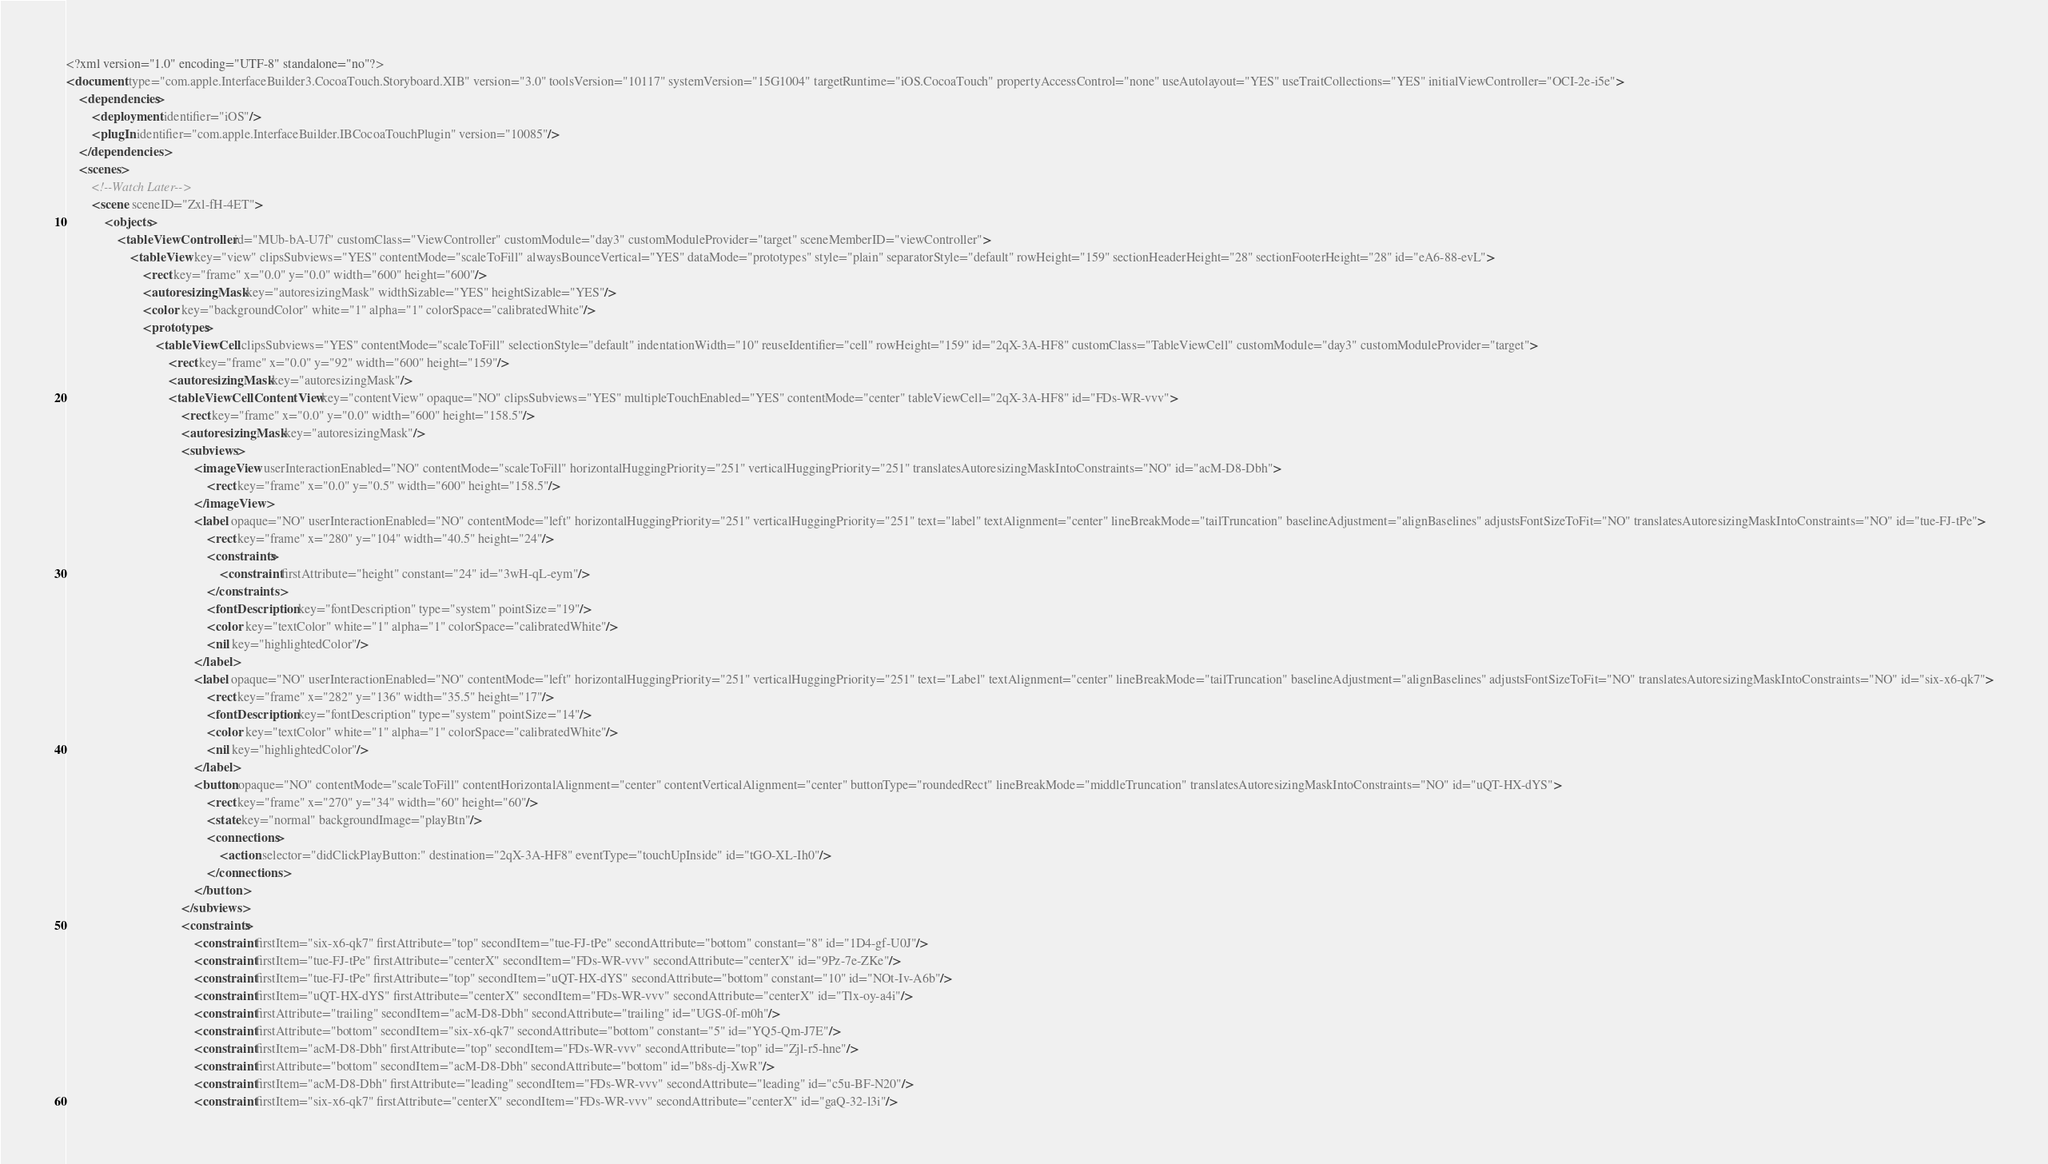<code> <loc_0><loc_0><loc_500><loc_500><_XML_><?xml version="1.0" encoding="UTF-8" standalone="no"?>
<document type="com.apple.InterfaceBuilder3.CocoaTouch.Storyboard.XIB" version="3.0" toolsVersion="10117" systemVersion="15G1004" targetRuntime="iOS.CocoaTouch" propertyAccessControl="none" useAutolayout="YES" useTraitCollections="YES" initialViewController="OCI-2e-i5e">
    <dependencies>
        <deployment identifier="iOS"/>
        <plugIn identifier="com.apple.InterfaceBuilder.IBCocoaTouchPlugin" version="10085"/>
    </dependencies>
    <scenes>
        <!--Watch Later-->
        <scene sceneID="Zxl-fH-4ET">
            <objects>
                <tableViewController id="MUb-bA-U7f" customClass="ViewController" customModule="day3" customModuleProvider="target" sceneMemberID="viewController">
                    <tableView key="view" clipsSubviews="YES" contentMode="scaleToFill" alwaysBounceVertical="YES" dataMode="prototypes" style="plain" separatorStyle="default" rowHeight="159" sectionHeaderHeight="28" sectionFooterHeight="28" id="eA6-88-evL">
                        <rect key="frame" x="0.0" y="0.0" width="600" height="600"/>
                        <autoresizingMask key="autoresizingMask" widthSizable="YES" heightSizable="YES"/>
                        <color key="backgroundColor" white="1" alpha="1" colorSpace="calibratedWhite"/>
                        <prototypes>
                            <tableViewCell clipsSubviews="YES" contentMode="scaleToFill" selectionStyle="default" indentationWidth="10" reuseIdentifier="cell" rowHeight="159" id="2qX-3A-HF8" customClass="TableViewCell" customModule="day3" customModuleProvider="target">
                                <rect key="frame" x="0.0" y="92" width="600" height="159"/>
                                <autoresizingMask key="autoresizingMask"/>
                                <tableViewCellContentView key="contentView" opaque="NO" clipsSubviews="YES" multipleTouchEnabled="YES" contentMode="center" tableViewCell="2qX-3A-HF8" id="FDs-WR-vvv">
                                    <rect key="frame" x="0.0" y="0.0" width="600" height="158.5"/>
                                    <autoresizingMask key="autoresizingMask"/>
                                    <subviews>
                                        <imageView userInteractionEnabled="NO" contentMode="scaleToFill" horizontalHuggingPriority="251" verticalHuggingPriority="251" translatesAutoresizingMaskIntoConstraints="NO" id="acM-D8-Dbh">
                                            <rect key="frame" x="0.0" y="0.5" width="600" height="158.5"/>
                                        </imageView>
                                        <label opaque="NO" userInteractionEnabled="NO" contentMode="left" horizontalHuggingPriority="251" verticalHuggingPriority="251" text="label" textAlignment="center" lineBreakMode="tailTruncation" baselineAdjustment="alignBaselines" adjustsFontSizeToFit="NO" translatesAutoresizingMaskIntoConstraints="NO" id="tue-FJ-tPe">
                                            <rect key="frame" x="280" y="104" width="40.5" height="24"/>
                                            <constraints>
                                                <constraint firstAttribute="height" constant="24" id="3wH-qL-eym"/>
                                            </constraints>
                                            <fontDescription key="fontDescription" type="system" pointSize="19"/>
                                            <color key="textColor" white="1" alpha="1" colorSpace="calibratedWhite"/>
                                            <nil key="highlightedColor"/>
                                        </label>
                                        <label opaque="NO" userInteractionEnabled="NO" contentMode="left" horizontalHuggingPriority="251" verticalHuggingPriority="251" text="Label" textAlignment="center" lineBreakMode="tailTruncation" baselineAdjustment="alignBaselines" adjustsFontSizeToFit="NO" translatesAutoresizingMaskIntoConstraints="NO" id="six-x6-qk7">
                                            <rect key="frame" x="282" y="136" width="35.5" height="17"/>
                                            <fontDescription key="fontDescription" type="system" pointSize="14"/>
                                            <color key="textColor" white="1" alpha="1" colorSpace="calibratedWhite"/>
                                            <nil key="highlightedColor"/>
                                        </label>
                                        <button opaque="NO" contentMode="scaleToFill" contentHorizontalAlignment="center" contentVerticalAlignment="center" buttonType="roundedRect" lineBreakMode="middleTruncation" translatesAutoresizingMaskIntoConstraints="NO" id="uQT-HX-dYS">
                                            <rect key="frame" x="270" y="34" width="60" height="60"/>
                                            <state key="normal" backgroundImage="playBtn"/>
                                            <connections>
                                                <action selector="didClickPlayButton:" destination="2qX-3A-HF8" eventType="touchUpInside" id="tGO-XL-Ih0"/>
                                            </connections>
                                        </button>
                                    </subviews>
                                    <constraints>
                                        <constraint firstItem="six-x6-qk7" firstAttribute="top" secondItem="tue-FJ-tPe" secondAttribute="bottom" constant="8" id="1D4-gf-U0J"/>
                                        <constraint firstItem="tue-FJ-tPe" firstAttribute="centerX" secondItem="FDs-WR-vvv" secondAttribute="centerX" id="9Pz-7e-ZKe"/>
                                        <constraint firstItem="tue-FJ-tPe" firstAttribute="top" secondItem="uQT-HX-dYS" secondAttribute="bottom" constant="10" id="NOt-Iv-A6b"/>
                                        <constraint firstItem="uQT-HX-dYS" firstAttribute="centerX" secondItem="FDs-WR-vvv" secondAttribute="centerX" id="Tlx-oy-a4i"/>
                                        <constraint firstAttribute="trailing" secondItem="acM-D8-Dbh" secondAttribute="trailing" id="UGS-0f-m0h"/>
                                        <constraint firstAttribute="bottom" secondItem="six-x6-qk7" secondAttribute="bottom" constant="5" id="YQ5-Qm-J7E"/>
                                        <constraint firstItem="acM-D8-Dbh" firstAttribute="top" secondItem="FDs-WR-vvv" secondAttribute="top" id="Zjl-r5-hne"/>
                                        <constraint firstAttribute="bottom" secondItem="acM-D8-Dbh" secondAttribute="bottom" id="b8s-dj-XwR"/>
                                        <constraint firstItem="acM-D8-Dbh" firstAttribute="leading" secondItem="FDs-WR-vvv" secondAttribute="leading" id="c5u-BF-N20"/>
                                        <constraint firstItem="six-x6-qk7" firstAttribute="centerX" secondItem="FDs-WR-vvv" secondAttribute="centerX" id="gaQ-32-l3i"/></code> 